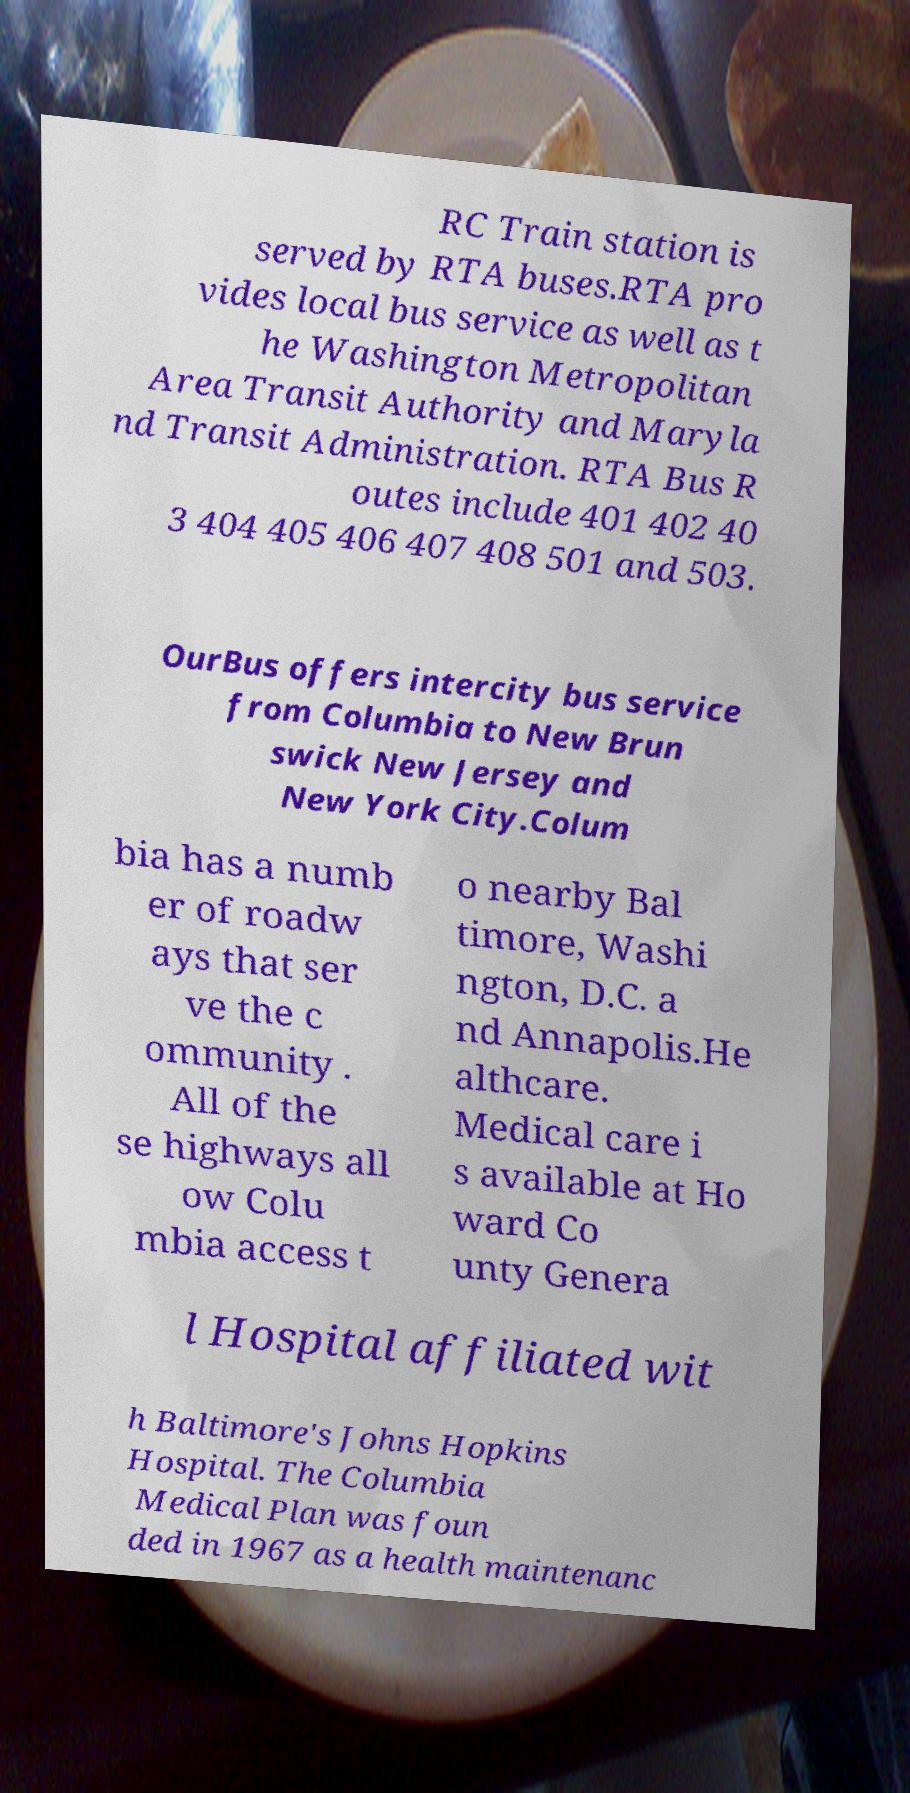Please identify and transcribe the text found in this image. RC Train station is served by RTA buses.RTA pro vides local bus service as well as t he Washington Metropolitan Area Transit Authority and Maryla nd Transit Administration. RTA Bus R outes include 401 402 40 3 404 405 406 407 408 501 and 503. OurBus offers intercity bus service from Columbia to New Brun swick New Jersey and New York City.Colum bia has a numb er of roadw ays that ser ve the c ommunity . All of the se highways all ow Colu mbia access t o nearby Bal timore, Washi ngton, D.C. a nd Annapolis.He althcare. Medical care i s available at Ho ward Co unty Genera l Hospital affiliated wit h Baltimore's Johns Hopkins Hospital. The Columbia Medical Plan was foun ded in 1967 as a health maintenanc 